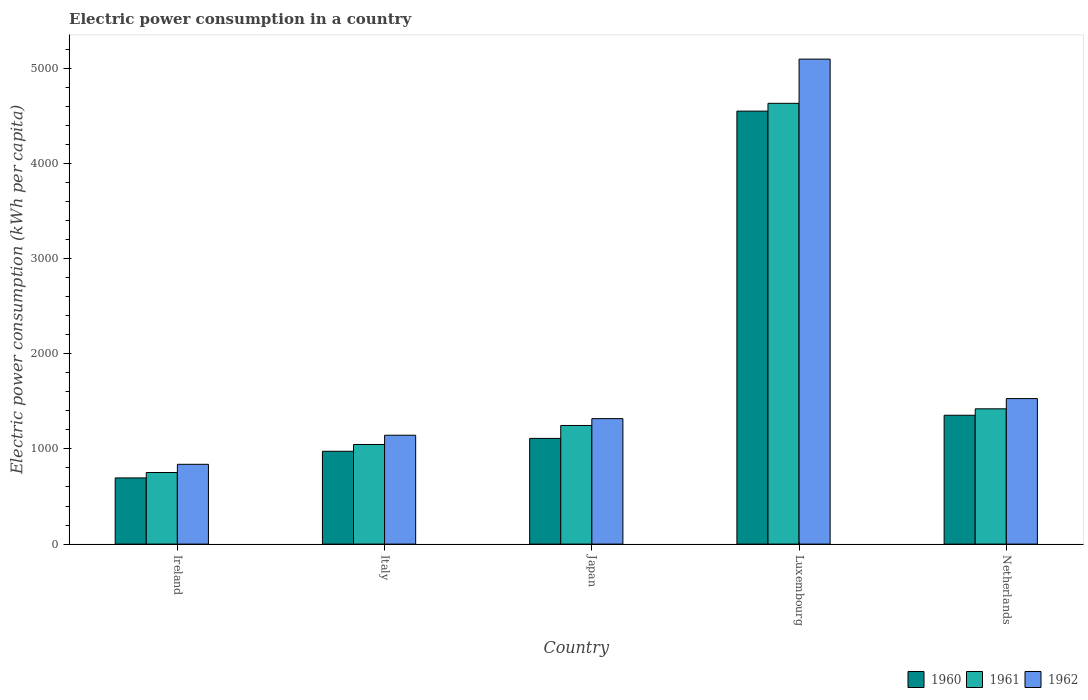How many bars are there on the 4th tick from the right?
Give a very brief answer. 3. What is the label of the 3rd group of bars from the left?
Your answer should be compact. Japan. What is the electric power consumption in in 1962 in Ireland?
Your answer should be very brief. 838.14. Across all countries, what is the maximum electric power consumption in in 1960?
Ensure brevity in your answer.  4548.21. Across all countries, what is the minimum electric power consumption in in 1962?
Offer a very short reply. 838.14. In which country was the electric power consumption in in 1961 maximum?
Your response must be concise. Luxembourg. In which country was the electric power consumption in in 1961 minimum?
Make the answer very short. Ireland. What is the total electric power consumption in in 1961 in the graph?
Offer a terse response. 9095.5. What is the difference between the electric power consumption in in 1960 in Ireland and that in Japan?
Offer a terse response. -415.22. What is the difference between the electric power consumption in in 1961 in Luxembourg and the electric power consumption in in 1960 in Japan?
Your response must be concise. 3519.76. What is the average electric power consumption in in 1960 per country?
Give a very brief answer. 1736.39. What is the difference between the electric power consumption in of/in 1961 and electric power consumption in of/in 1962 in Netherlands?
Ensure brevity in your answer.  -107.47. In how many countries, is the electric power consumption in in 1961 greater than 400 kWh per capita?
Your response must be concise. 5. What is the ratio of the electric power consumption in in 1960 in Ireland to that in Netherlands?
Make the answer very short. 0.51. Is the electric power consumption in in 1962 in Japan less than that in Netherlands?
Give a very brief answer. Yes. What is the difference between the highest and the second highest electric power consumption in in 1960?
Make the answer very short. -3194.81. What is the difference between the highest and the lowest electric power consumption in in 1961?
Offer a very short reply. 3878.01. In how many countries, is the electric power consumption in in 1962 greater than the average electric power consumption in in 1962 taken over all countries?
Offer a very short reply. 1. Is the sum of the electric power consumption in in 1960 in Japan and Netherlands greater than the maximum electric power consumption in in 1962 across all countries?
Offer a very short reply. No. What does the 2nd bar from the left in Ireland represents?
Make the answer very short. 1961. Is it the case that in every country, the sum of the electric power consumption in in 1961 and electric power consumption in in 1960 is greater than the electric power consumption in in 1962?
Ensure brevity in your answer.  Yes. How many bars are there?
Make the answer very short. 15. Does the graph contain any zero values?
Your answer should be very brief. No. Does the graph contain grids?
Keep it short and to the point. No. Where does the legend appear in the graph?
Provide a short and direct response. Bottom right. How are the legend labels stacked?
Ensure brevity in your answer.  Horizontal. What is the title of the graph?
Provide a short and direct response. Electric power consumption in a country. Does "2008" appear as one of the legend labels in the graph?
Your response must be concise. No. What is the label or title of the Y-axis?
Offer a terse response. Electric power consumption (kWh per capita). What is the Electric power consumption (kWh per capita) of 1960 in Ireland?
Keep it short and to the point. 695.04. What is the Electric power consumption (kWh per capita) of 1961 in Ireland?
Give a very brief answer. 752.02. What is the Electric power consumption (kWh per capita) of 1962 in Ireland?
Make the answer very short. 838.14. What is the Electric power consumption (kWh per capita) in 1960 in Italy?
Offer a very short reply. 975.03. What is the Electric power consumption (kWh per capita) of 1961 in Italy?
Your response must be concise. 1046.42. What is the Electric power consumption (kWh per capita) of 1962 in Italy?
Give a very brief answer. 1143.61. What is the Electric power consumption (kWh per capita) of 1960 in Japan?
Offer a very short reply. 1110.26. What is the Electric power consumption (kWh per capita) in 1961 in Japan?
Provide a succinct answer. 1246.01. What is the Electric power consumption (kWh per capita) of 1962 in Japan?
Provide a succinct answer. 1317.93. What is the Electric power consumption (kWh per capita) in 1960 in Luxembourg?
Provide a succinct answer. 4548.21. What is the Electric power consumption (kWh per capita) in 1961 in Luxembourg?
Ensure brevity in your answer.  4630.02. What is the Electric power consumption (kWh per capita) of 1962 in Luxembourg?
Offer a terse response. 5094.31. What is the Electric power consumption (kWh per capita) in 1960 in Netherlands?
Offer a terse response. 1353.4. What is the Electric power consumption (kWh per capita) in 1961 in Netherlands?
Offer a terse response. 1421.03. What is the Electric power consumption (kWh per capita) in 1962 in Netherlands?
Your answer should be very brief. 1528.5. Across all countries, what is the maximum Electric power consumption (kWh per capita) in 1960?
Your response must be concise. 4548.21. Across all countries, what is the maximum Electric power consumption (kWh per capita) in 1961?
Provide a short and direct response. 4630.02. Across all countries, what is the maximum Electric power consumption (kWh per capita) in 1962?
Make the answer very short. 5094.31. Across all countries, what is the minimum Electric power consumption (kWh per capita) in 1960?
Your response must be concise. 695.04. Across all countries, what is the minimum Electric power consumption (kWh per capita) of 1961?
Your answer should be very brief. 752.02. Across all countries, what is the minimum Electric power consumption (kWh per capita) of 1962?
Your answer should be very brief. 838.14. What is the total Electric power consumption (kWh per capita) in 1960 in the graph?
Your answer should be compact. 8681.94. What is the total Electric power consumption (kWh per capita) in 1961 in the graph?
Your response must be concise. 9095.5. What is the total Electric power consumption (kWh per capita) of 1962 in the graph?
Offer a terse response. 9922.48. What is the difference between the Electric power consumption (kWh per capita) in 1960 in Ireland and that in Italy?
Provide a succinct answer. -279.98. What is the difference between the Electric power consumption (kWh per capita) in 1961 in Ireland and that in Italy?
Offer a very short reply. -294.4. What is the difference between the Electric power consumption (kWh per capita) of 1962 in Ireland and that in Italy?
Your response must be concise. -305.47. What is the difference between the Electric power consumption (kWh per capita) of 1960 in Ireland and that in Japan?
Your answer should be compact. -415.22. What is the difference between the Electric power consumption (kWh per capita) of 1961 in Ireland and that in Japan?
Your answer should be very brief. -493.99. What is the difference between the Electric power consumption (kWh per capita) of 1962 in Ireland and that in Japan?
Offer a terse response. -479.79. What is the difference between the Electric power consumption (kWh per capita) of 1960 in Ireland and that in Luxembourg?
Make the answer very short. -3853.16. What is the difference between the Electric power consumption (kWh per capita) of 1961 in Ireland and that in Luxembourg?
Give a very brief answer. -3878.01. What is the difference between the Electric power consumption (kWh per capita) in 1962 in Ireland and that in Luxembourg?
Provide a succinct answer. -4256.17. What is the difference between the Electric power consumption (kWh per capita) of 1960 in Ireland and that in Netherlands?
Make the answer very short. -658.36. What is the difference between the Electric power consumption (kWh per capita) in 1961 in Ireland and that in Netherlands?
Provide a succinct answer. -669.02. What is the difference between the Electric power consumption (kWh per capita) of 1962 in Ireland and that in Netherlands?
Provide a succinct answer. -690.36. What is the difference between the Electric power consumption (kWh per capita) of 1960 in Italy and that in Japan?
Provide a succinct answer. -135.24. What is the difference between the Electric power consumption (kWh per capita) of 1961 in Italy and that in Japan?
Your answer should be very brief. -199.6. What is the difference between the Electric power consumption (kWh per capita) in 1962 in Italy and that in Japan?
Your answer should be compact. -174.33. What is the difference between the Electric power consumption (kWh per capita) of 1960 in Italy and that in Luxembourg?
Make the answer very short. -3573.18. What is the difference between the Electric power consumption (kWh per capita) in 1961 in Italy and that in Luxembourg?
Provide a short and direct response. -3583.61. What is the difference between the Electric power consumption (kWh per capita) of 1962 in Italy and that in Luxembourg?
Give a very brief answer. -3950.71. What is the difference between the Electric power consumption (kWh per capita) of 1960 in Italy and that in Netherlands?
Provide a succinct answer. -378.37. What is the difference between the Electric power consumption (kWh per capita) in 1961 in Italy and that in Netherlands?
Provide a short and direct response. -374.62. What is the difference between the Electric power consumption (kWh per capita) in 1962 in Italy and that in Netherlands?
Ensure brevity in your answer.  -384.9. What is the difference between the Electric power consumption (kWh per capita) of 1960 in Japan and that in Luxembourg?
Ensure brevity in your answer.  -3437.94. What is the difference between the Electric power consumption (kWh per capita) of 1961 in Japan and that in Luxembourg?
Provide a succinct answer. -3384.01. What is the difference between the Electric power consumption (kWh per capita) of 1962 in Japan and that in Luxembourg?
Your response must be concise. -3776.38. What is the difference between the Electric power consumption (kWh per capita) of 1960 in Japan and that in Netherlands?
Ensure brevity in your answer.  -243.14. What is the difference between the Electric power consumption (kWh per capita) of 1961 in Japan and that in Netherlands?
Your answer should be very brief. -175.02. What is the difference between the Electric power consumption (kWh per capita) of 1962 in Japan and that in Netherlands?
Provide a short and direct response. -210.57. What is the difference between the Electric power consumption (kWh per capita) of 1960 in Luxembourg and that in Netherlands?
Your answer should be compact. 3194.81. What is the difference between the Electric power consumption (kWh per capita) in 1961 in Luxembourg and that in Netherlands?
Your response must be concise. 3208.99. What is the difference between the Electric power consumption (kWh per capita) of 1962 in Luxembourg and that in Netherlands?
Make the answer very short. 3565.81. What is the difference between the Electric power consumption (kWh per capita) in 1960 in Ireland and the Electric power consumption (kWh per capita) in 1961 in Italy?
Make the answer very short. -351.37. What is the difference between the Electric power consumption (kWh per capita) of 1960 in Ireland and the Electric power consumption (kWh per capita) of 1962 in Italy?
Keep it short and to the point. -448.56. What is the difference between the Electric power consumption (kWh per capita) of 1961 in Ireland and the Electric power consumption (kWh per capita) of 1962 in Italy?
Your response must be concise. -391.59. What is the difference between the Electric power consumption (kWh per capita) of 1960 in Ireland and the Electric power consumption (kWh per capita) of 1961 in Japan?
Make the answer very short. -550.97. What is the difference between the Electric power consumption (kWh per capita) of 1960 in Ireland and the Electric power consumption (kWh per capita) of 1962 in Japan?
Your response must be concise. -622.89. What is the difference between the Electric power consumption (kWh per capita) in 1961 in Ireland and the Electric power consumption (kWh per capita) in 1962 in Japan?
Your answer should be compact. -565.91. What is the difference between the Electric power consumption (kWh per capita) in 1960 in Ireland and the Electric power consumption (kWh per capita) in 1961 in Luxembourg?
Your answer should be very brief. -3934.98. What is the difference between the Electric power consumption (kWh per capita) in 1960 in Ireland and the Electric power consumption (kWh per capita) in 1962 in Luxembourg?
Provide a short and direct response. -4399.27. What is the difference between the Electric power consumption (kWh per capita) in 1961 in Ireland and the Electric power consumption (kWh per capita) in 1962 in Luxembourg?
Offer a terse response. -4342.29. What is the difference between the Electric power consumption (kWh per capita) of 1960 in Ireland and the Electric power consumption (kWh per capita) of 1961 in Netherlands?
Offer a very short reply. -725.99. What is the difference between the Electric power consumption (kWh per capita) of 1960 in Ireland and the Electric power consumption (kWh per capita) of 1962 in Netherlands?
Offer a terse response. -833.46. What is the difference between the Electric power consumption (kWh per capita) in 1961 in Ireland and the Electric power consumption (kWh per capita) in 1962 in Netherlands?
Provide a short and direct response. -776.48. What is the difference between the Electric power consumption (kWh per capita) in 1960 in Italy and the Electric power consumption (kWh per capita) in 1961 in Japan?
Provide a succinct answer. -270.99. What is the difference between the Electric power consumption (kWh per capita) of 1960 in Italy and the Electric power consumption (kWh per capita) of 1962 in Japan?
Provide a short and direct response. -342.91. What is the difference between the Electric power consumption (kWh per capita) of 1961 in Italy and the Electric power consumption (kWh per capita) of 1962 in Japan?
Your response must be concise. -271.52. What is the difference between the Electric power consumption (kWh per capita) in 1960 in Italy and the Electric power consumption (kWh per capita) in 1961 in Luxembourg?
Ensure brevity in your answer.  -3655. What is the difference between the Electric power consumption (kWh per capita) in 1960 in Italy and the Electric power consumption (kWh per capita) in 1962 in Luxembourg?
Your answer should be compact. -4119.28. What is the difference between the Electric power consumption (kWh per capita) of 1961 in Italy and the Electric power consumption (kWh per capita) of 1962 in Luxembourg?
Your answer should be very brief. -4047.9. What is the difference between the Electric power consumption (kWh per capita) in 1960 in Italy and the Electric power consumption (kWh per capita) in 1961 in Netherlands?
Your response must be concise. -446.01. What is the difference between the Electric power consumption (kWh per capita) in 1960 in Italy and the Electric power consumption (kWh per capita) in 1962 in Netherlands?
Your response must be concise. -553.47. What is the difference between the Electric power consumption (kWh per capita) of 1961 in Italy and the Electric power consumption (kWh per capita) of 1962 in Netherlands?
Provide a short and direct response. -482.09. What is the difference between the Electric power consumption (kWh per capita) in 1960 in Japan and the Electric power consumption (kWh per capita) in 1961 in Luxembourg?
Offer a very short reply. -3519.76. What is the difference between the Electric power consumption (kWh per capita) in 1960 in Japan and the Electric power consumption (kWh per capita) in 1962 in Luxembourg?
Keep it short and to the point. -3984.05. What is the difference between the Electric power consumption (kWh per capita) of 1961 in Japan and the Electric power consumption (kWh per capita) of 1962 in Luxembourg?
Provide a succinct answer. -3848.3. What is the difference between the Electric power consumption (kWh per capita) in 1960 in Japan and the Electric power consumption (kWh per capita) in 1961 in Netherlands?
Your answer should be compact. -310.77. What is the difference between the Electric power consumption (kWh per capita) of 1960 in Japan and the Electric power consumption (kWh per capita) of 1962 in Netherlands?
Provide a succinct answer. -418.24. What is the difference between the Electric power consumption (kWh per capita) in 1961 in Japan and the Electric power consumption (kWh per capita) in 1962 in Netherlands?
Provide a succinct answer. -282.49. What is the difference between the Electric power consumption (kWh per capita) of 1960 in Luxembourg and the Electric power consumption (kWh per capita) of 1961 in Netherlands?
Offer a very short reply. 3127.17. What is the difference between the Electric power consumption (kWh per capita) in 1960 in Luxembourg and the Electric power consumption (kWh per capita) in 1962 in Netherlands?
Keep it short and to the point. 3019.7. What is the difference between the Electric power consumption (kWh per capita) in 1961 in Luxembourg and the Electric power consumption (kWh per capita) in 1962 in Netherlands?
Offer a terse response. 3101.52. What is the average Electric power consumption (kWh per capita) in 1960 per country?
Provide a short and direct response. 1736.39. What is the average Electric power consumption (kWh per capita) of 1961 per country?
Keep it short and to the point. 1819.1. What is the average Electric power consumption (kWh per capita) of 1962 per country?
Provide a succinct answer. 1984.5. What is the difference between the Electric power consumption (kWh per capita) of 1960 and Electric power consumption (kWh per capita) of 1961 in Ireland?
Offer a terse response. -56.97. What is the difference between the Electric power consumption (kWh per capita) of 1960 and Electric power consumption (kWh per capita) of 1962 in Ireland?
Make the answer very short. -143.09. What is the difference between the Electric power consumption (kWh per capita) in 1961 and Electric power consumption (kWh per capita) in 1962 in Ireland?
Offer a terse response. -86.12. What is the difference between the Electric power consumption (kWh per capita) of 1960 and Electric power consumption (kWh per capita) of 1961 in Italy?
Ensure brevity in your answer.  -71.39. What is the difference between the Electric power consumption (kWh per capita) of 1960 and Electric power consumption (kWh per capita) of 1962 in Italy?
Offer a very short reply. -168.58. What is the difference between the Electric power consumption (kWh per capita) in 1961 and Electric power consumption (kWh per capita) in 1962 in Italy?
Provide a succinct answer. -97.19. What is the difference between the Electric power consumption (kWh per capita) of 1960 and Electric power consumption (kWh per capita) of 1961 in Japan?
Your answer should be very brief. -135.75. What is the difference between the Electric power consumption (kWh per capita) of 1960 and Electric power consumption (kWh per capita) of 1962 in Japan?
Make the answer very short. -207.67. What is the difference between the Electric power consumption (kWh per capita) in 1961 and Electric power consumption (kWh per capita) in 1962 in Japan?
Make the answer very short. -71.92. What is the difference between the Electric power consumption (kWh per capita) of 1960 and Electric power consumption (kWh per capita) of 1961 in Luxembourg?
Keep it short and to the point. -81.82. What is the difference between the Electric power consumption (kWh per capita) in 1960 and Electric power consumption (kWh per capita) in 1962 in Luxembourg?
Ensure brevity in your answer.  -546.11. What is the difference between the Electric power consumption (kWh per capita) of 1961 and Electric power consumption (kWh per capita) of 1962 in Luxembourg?
Your answer should be compact. -464.29. What is the difference between the Electric power consumption (kWh per capita) in 1960 and Electric power consumption (kWh per capita) in 1961 in Netherlands?
Your response must be concise. -67.63. What is the difference between the Electric power consumption (kWh per capita) of 1960 and Electric power consumption (kWh per capita) of 1962 in Netherlands?
Ensure brevity in your answer.  -175.1. What is the difference between the Electric power consumption (kWh per capita) of 1961 and Electric power consumption (kWh per capita) of 1962 in Netherlands?
Keep it short and to the point. -107.47. What is the ratio of the Electric power consumption (kWh per capita) in 1960 in Ireland to that in Italy?
Your answer should be very brief. 0.71. What is the ratio of the Electric power consumption (kWh per capita) of 1961 in Ireland to that in Italy?
Your answer should be compact. 0.72. What is the ratio of the Electric power consumption (kWh per capita) in 1962 in Ireland to that in Italy?
Your answer should be compact. 0.73. What is the ratio of the Electric power consumption (kWh per capita) in 1960 in Ireland to that in Japan?
Ensure brevity in your answer.  0.63. What is the ratio of the Electric power consumption (kWh per capita) of 1961 in Ireland to that in Japan?
Keep it short and to the point. 0.6. What is the ratio of the Electric power consumption (kWh per capita) of 1962 in Ireland to that in Japan?
Provide a short and direct response. 0.64. What is the ratio of the Electric power consumption (kWh per capita) in 1960 in Ireland to that in Luxembourg?
Provide a succinct answer. 0.15. What is the ratio of the Electric power consumption (kWh per capita) of 1961 in Ireland to that in Luxembourg?
Provide a short and direct response. 0.16. What is the ratio of the Electric power consumption (kWh per capita) of 1962 in Ireland to that in Luxembourg?
Your answer should be compact. 0.16. What is the ratio of the Electric power consumption (kWh per capita) in 1960 in Ireland to that in Netherlands?
Ensure brevity in your answer.  0.51. What is the ratio of the Electric power consumption (kWh per capita) of 1961 in Ireland to that in Netherlands?
Provide a succinct answer. 0.53. What is the ratio of the Electric power consumption (kWh per capita) of 1962 in Ireland to that in Netherlands?
Keep it short and to the point. 0.55. What is the ratio of the Electric power consumption (kWh per capita) of 1960 in Italy to that in Japan?
Make the answer very short. 0.88. What is the ratio of the Electric power consumption (kWh per capita) in 1961 in Italy to that in Japan?
Your response must be concise. 0.84. What is the ratio of the Electric power consumption (kWh per capita) in 1962 in Italy to that in Japan?
Provide a succinct answer. 0.87. What is the ratio of the Electric power consumption (kWh per capita) in 1960 in Italy to that in Luxembourg?
Offer a very short reply. 0.21. What is the ratio of the Electric power consumption (kWh per capita) in 1961 in Italy to that in Luxembourg?
Your response must be concise. 0.23. What is the ratio of the Electric power consumption (kWh per capita) in 1962 in Italy to that in Luxembourg?
Offer a very short reply. 0.22. What is the ratio of the Electric power consumption (kWh per capita) in 1960 in Italy to that in Netherlands?
Your answer should be compact. 0.72. What is the ratio of the Electric power consumption (kWh per capita) in 1961 in Italy to that in Netherlands?
Your response must be concise. 0.74. What is the ratio of the Electric power consumption (kWh per capita) of 1962 in Italy to that in Netherlands?
Give a very brief answer. 0.75. What is the ratio of the Electric power consumption (kWh per capita) in 1960 in Japan to that in Luxembourg?
Your answer should be compact. 0.24. What is the ratio of the Electric power consumption (kWh per capita) of 1961 in Japan to that in Luxembourg?
Keep it short and to the point. 0.27. What is the ratio of the Electric power consumption (kWh per capita) in 1962 in Japan to that in Luxembourg?
Keep it short and to the point. 0.26. What is the ratio of the Electric power consumption (kWh per capita) of 1960 in Japan to that in Netherlands?
Provide a short and direct response. 0.82. What is the ratio of the Electric power consumption (kWh per capita) of 1961 in Japan to that in Netherlands?
Keep it short and to the point. 0.88. What is the ratio of the Electric power consumption (kWh per capita) of 1962 in Japan to that in Netherlands?
Your answer should be very brief. 0.86. What is the ratio of the Electric power consumption (kWh per capita) in 1960 in Luxembourg to that in Netherlands?
Your answer should be compact. 3.36. What is the ratio of the Electric power consumption (kWh per capita) of 1961 in Luxembourg to that in Netherlands?
Give a very brief answer. 3.26. What is the ratio of the Electric power consumption (kWh per capita) in 1962 in Luxembourg to that in Netherlands?
Your answer should be compact. 3.33. What is the difference between the highest and the second highest Electric power consumption (kWh per capita) of 1960?
Ensure brevity in your answer.  3194.81. What is the difference between the highest and the second highest Electric power consumption (kWh per capita) in 1961?
Offer a terse response. 3208.99. What is the difference between the highest and the second highest Electric power consumption (kWh per capita) in 1962?
Give a very brief answer. 3565.81. What is the difference between the highest and the lowest Electric power consumption (kWh per capita) of 1960?
Offer a terse response. 3853.16. What is the difference between the highest and the lowest Electric power consumption (kWh per capita) of 1961?
Ensure brevity in your answer.  3878.01. What is the difference between the highest and the lowest Electric power consumption (kWh per capita) in 1962?
Keep it short and to the point. 4256.17. 